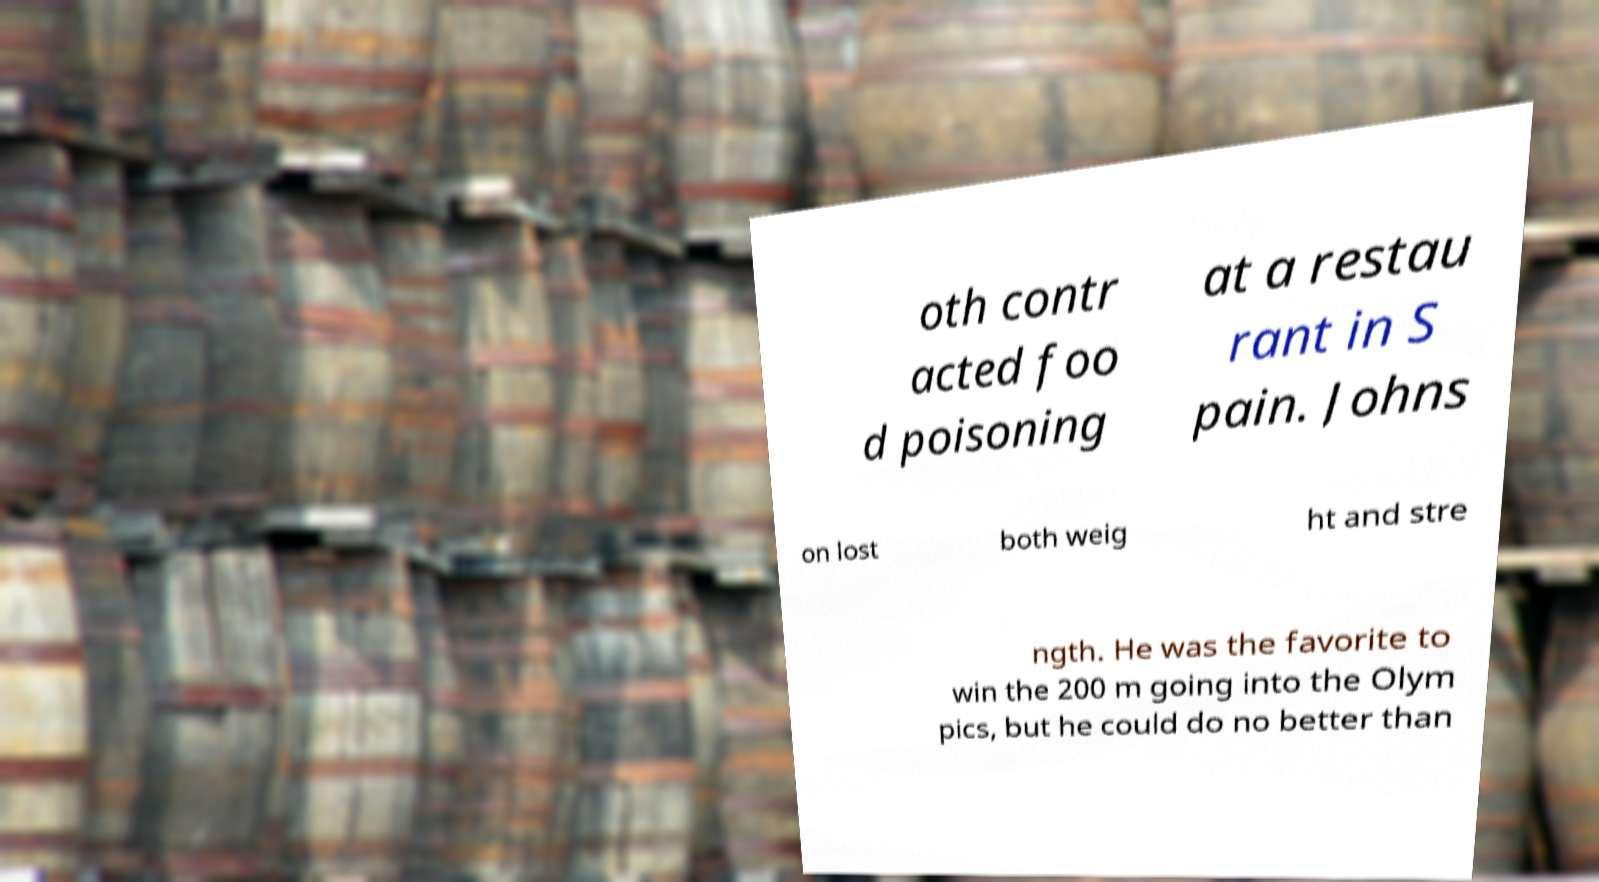I need the written content from this picture converted into text. Can you do that? oth contr acted foo d poisoning at a restau rant in S pain. Johns on lost both weig ht and stre ngth. He was the favorite to win the 200 m going into the Olym pics, but he could do no better than 